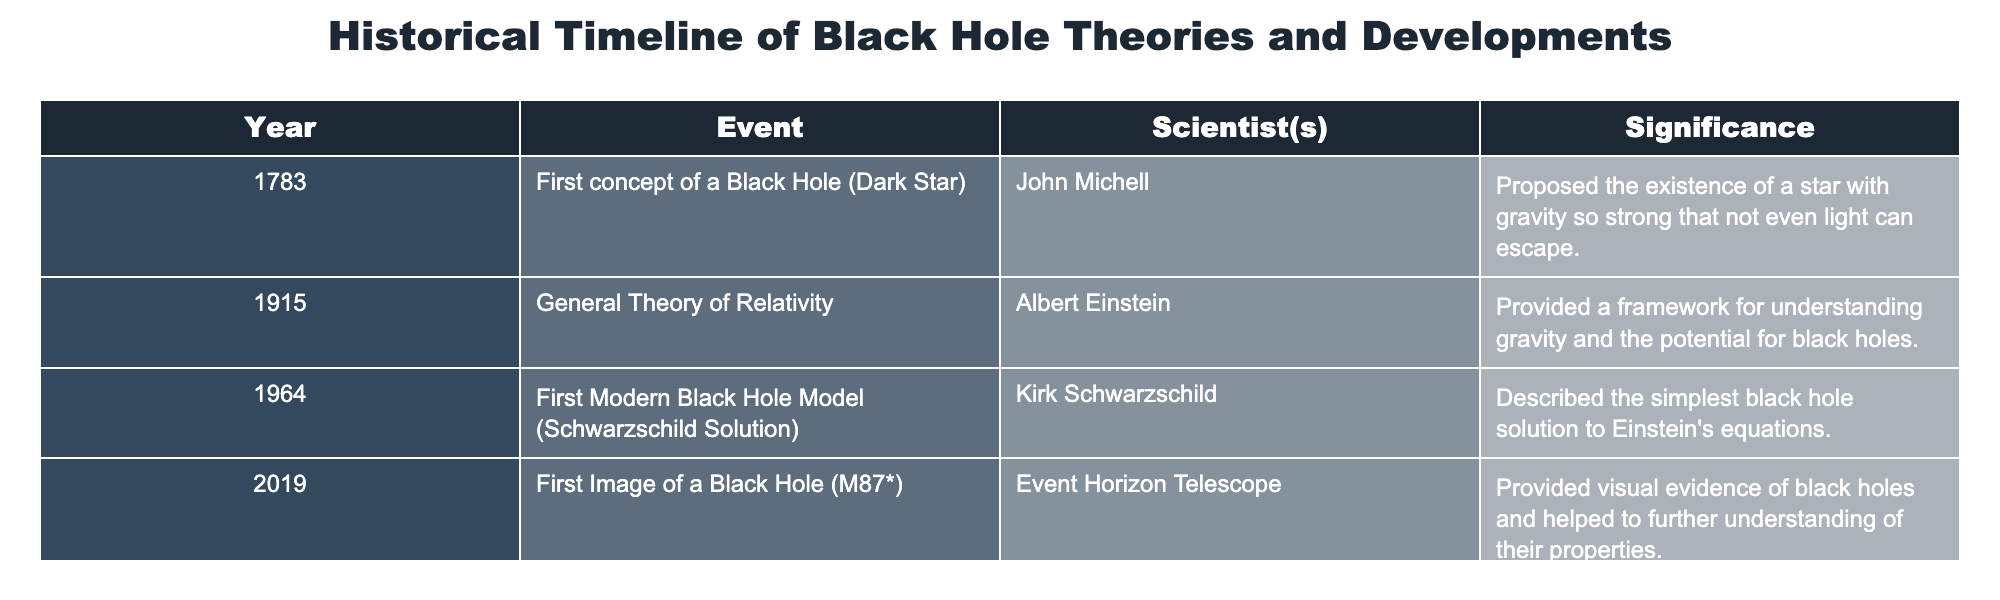What year was the first concept of a black hole proposed? The table lists an event from 1783 where John Michell proposed the first concept of a black hole, also referred to as a "Dark Star." Thus, the year is clearly stated in that row.
Answer: 1783 Who described the first modern black hole model? Referring to the table, the row for 1964 indicates that Kirk Schwarzschild described the first modern black hole model, specifically the Schwarzschild solution.
Answer: Kirk Schwarzschild Was the general theory of relativity developed before or after 1964? According to the table, the general theory of relativity was developed in 1915, which is before 1964, as indicated by the respective years listed in the events.
Answer: Before What is the significance of the first image of a black hole? The table indicates that the significance of the first image of a black hole captured in 2019 is that it provided visual evidence of black holes and helped deepen understanding of their properties.
Answer: Provided visual evidence and deepened understanding How many events occurred before the year 2000? From the table, there are three events (1783, 1915, and 1964) that occurred before 2000. The events are clearly visible and can be counted directly.
Answer: 3 Did John Michell's proposition refer to a star from which light cannot escape? The table mentions that John Michell proposed a star with gravity so strong that not even light can escape, confirming that his concept indeed referred to such a star.
Answer: Yes What is the chronological order of the events listed in the table? The chronological order based on the years provided in the table is: 1783 (First concept), 1915 (General Theory), 1964 (Modern Model), 2019 (First Image). This order can be easily deduced from the years in each row.
Answer: 1783, 1915, 1964, 2019 How does the number of significant black hole developments compare between the 20th century and the 21st century? In the table, three developments are listed in the 20th century (1783, 1915, 1964) and one in the 21st century (2019). Therefore, the 20th century has more significant developments than the 21st century, by two events.
Answer: 20th century has more (3 vs 1) 